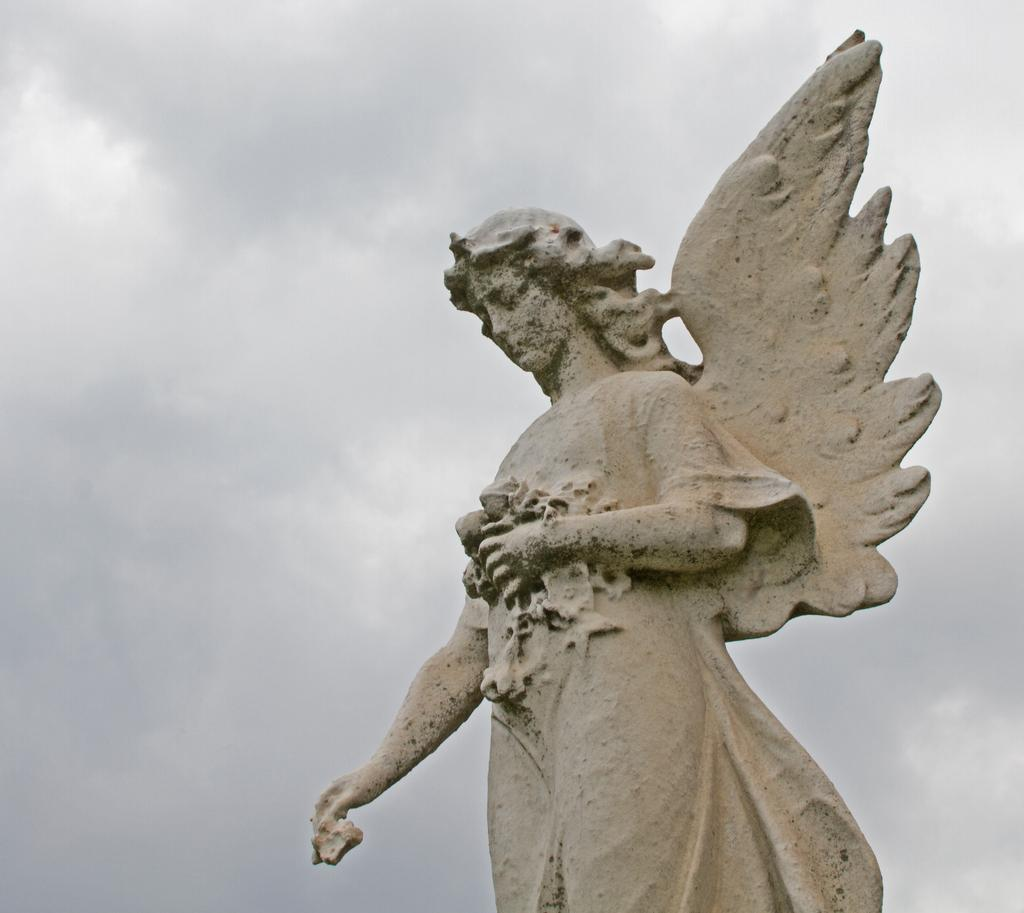What is the main subject of the image? There is a statue in the image. Can you describe the statue? The statue resembles an angel. What can be seen in the background of the image? The sky is visible in the background of the image. How would you describe the sky in the image? The sky appears to be cloudy. What type of afternoon can be seen in the image? There is no reference to an afternoon in the image, as it features a statue and a cloudy sky. 